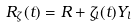Convert formula to latex. <formula><loc_0><loc_0><loc_500><loc_500>R _ { \zeta } ( t ) = R + \zeta _ { l } ( t ) Y _ { l }</formula> 